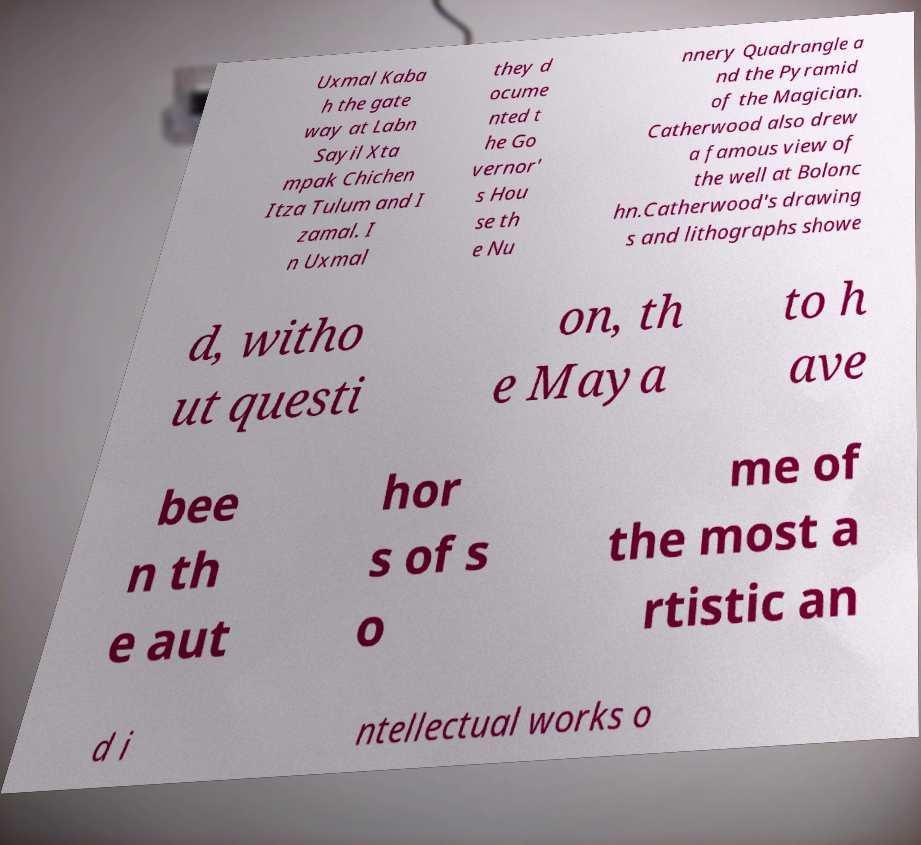Can you accurately transcribe the text from the provided image for me? Uxmal Kaba h the gate way at Labn Sayil Xta mpak Chichen Itza Tulum and I zamal. I n Uxmal they d ocume nted t he Go vernor' s Hou se th e Nu nnery Quadrangle a nd the Pyramid of the Magician. Catherwood also drew a famous view of the well at Bolonc hn.Catherwood's drawing s and lithographs showe d, witho ut questi on, th e Maya to h ave bee n th e aut hor s of s o me of the most a rtistic an d i ntellectual works o 